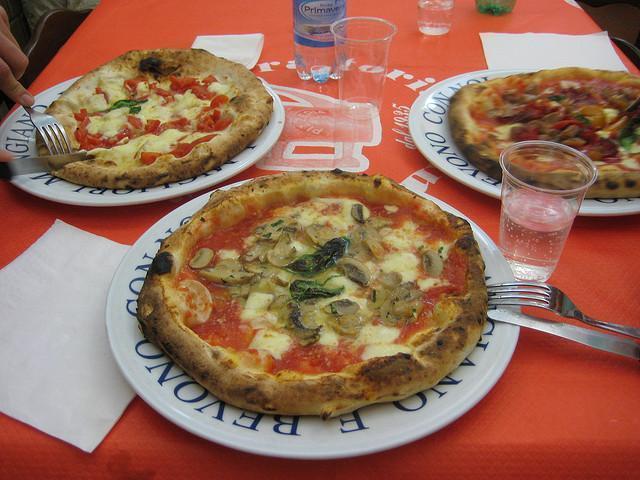Verify the accuracy of this image caption: "The person is at the left side of the dining table.".
Answer yes or no. Yes. 